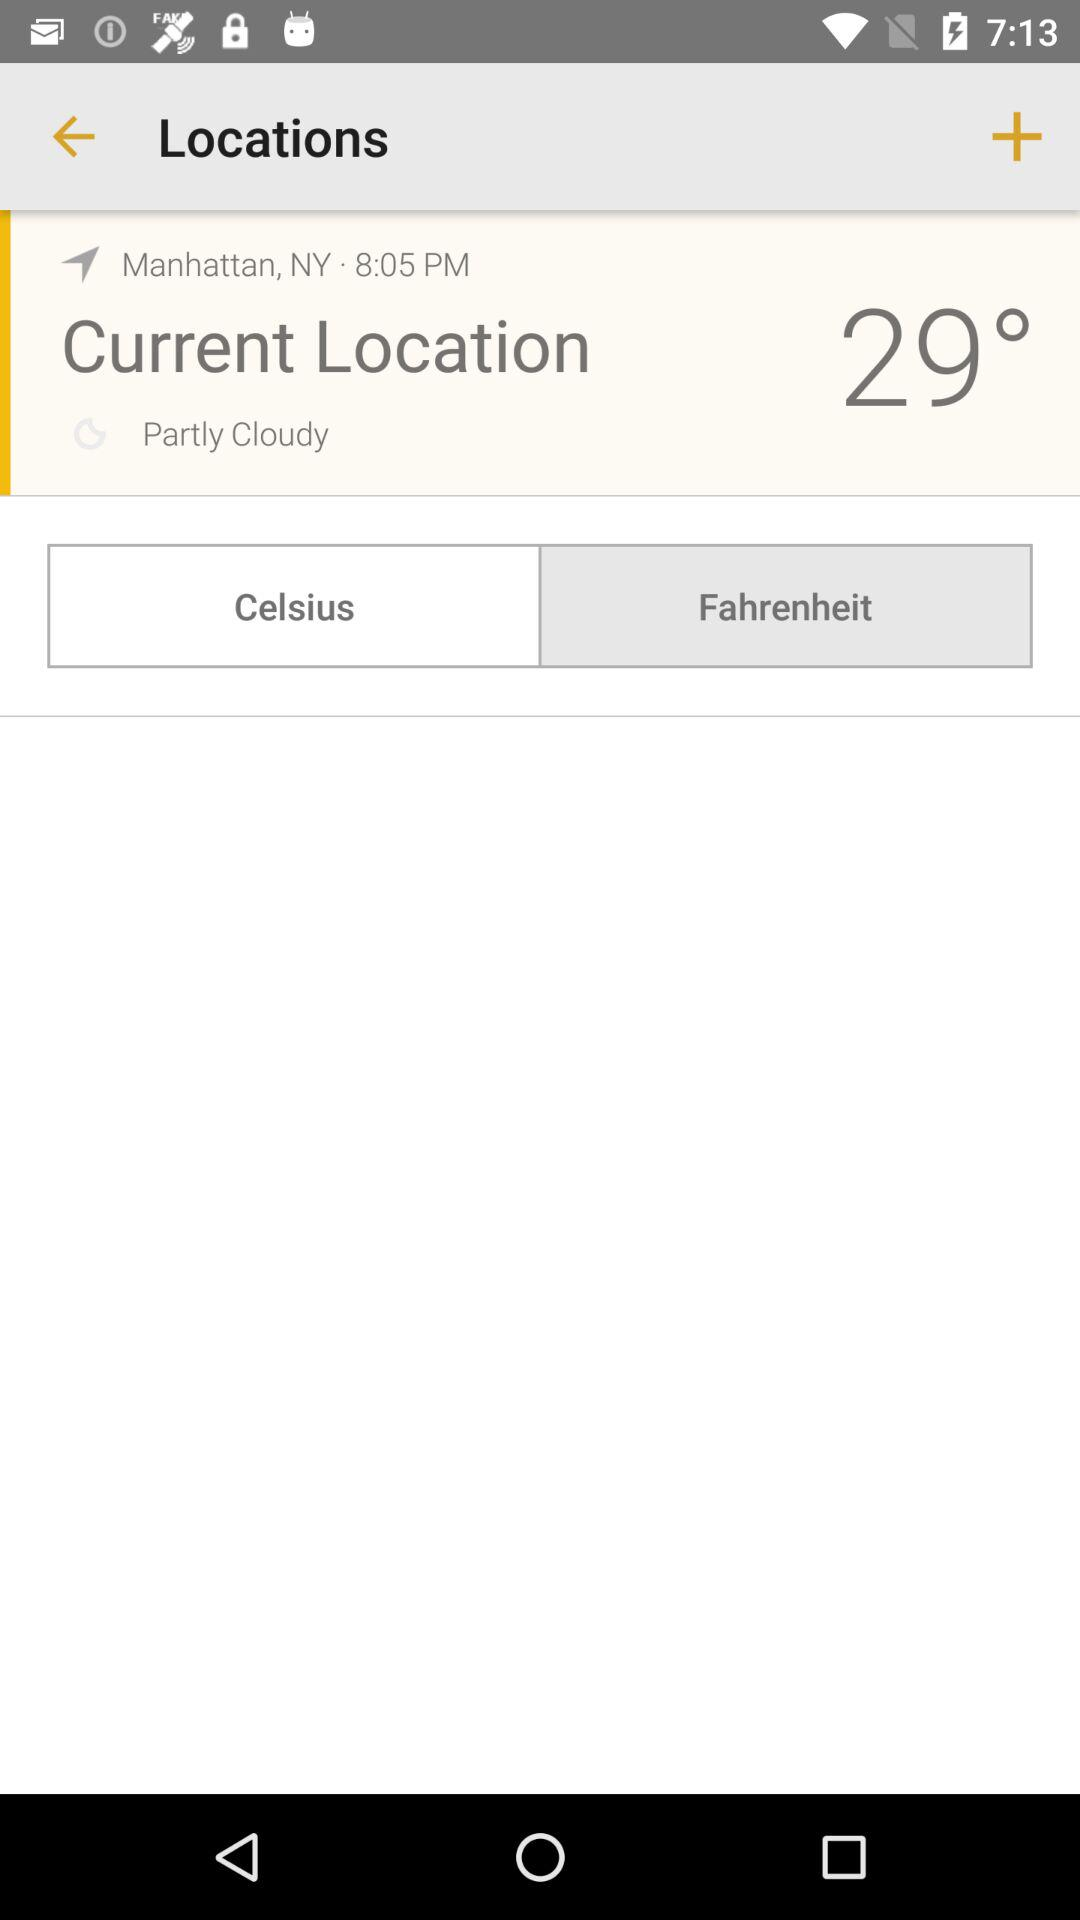How's the weather? The weather is partly cloudy. 